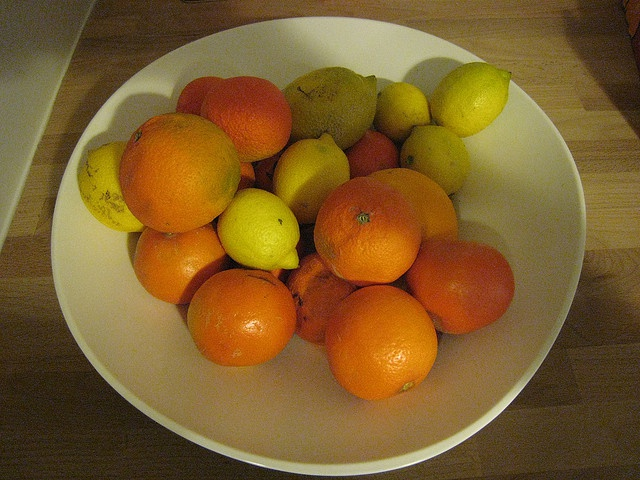Describe the objects in this image and their specific colors. I can see dining table in olive, maroon, black, and tan tones, bowl in darkgreen, brown, tan, and olive tones, orange in darkgreen, red, orange, olive, and maroon tones, orange in darkgreen, orange, red, and maroon tones, and orange in darkgreen, brown, orange, and maroon tones in this image. 